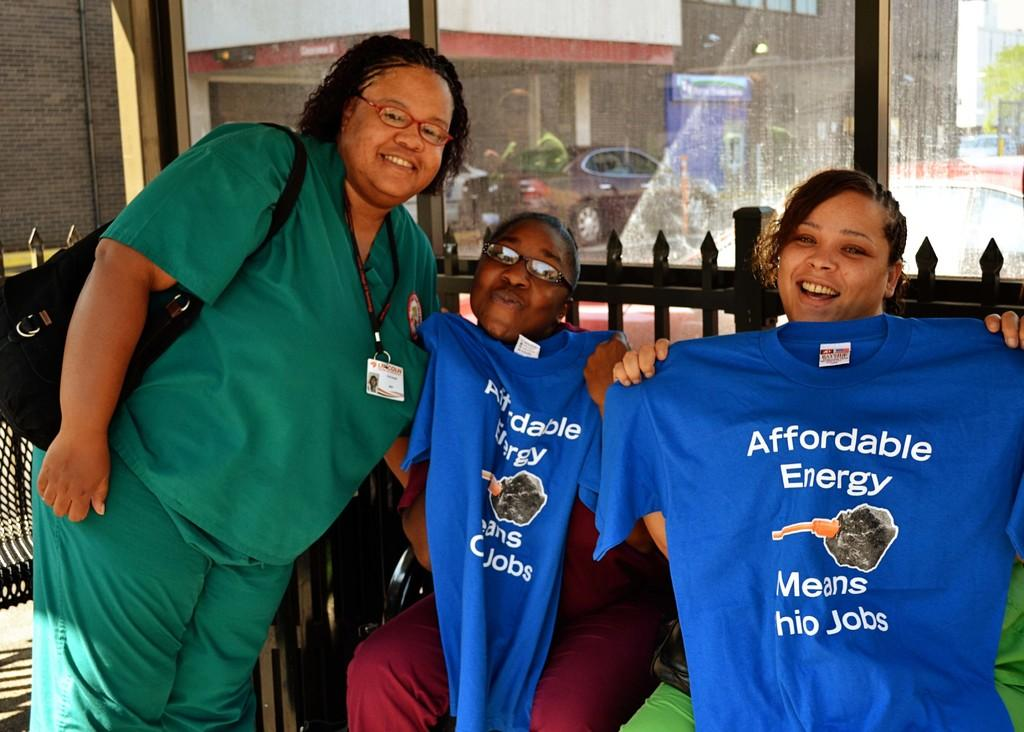<image>
Render a clear and concise summary of the photo. The two girls with the blue t-shirt are advocating for affordable energy. 